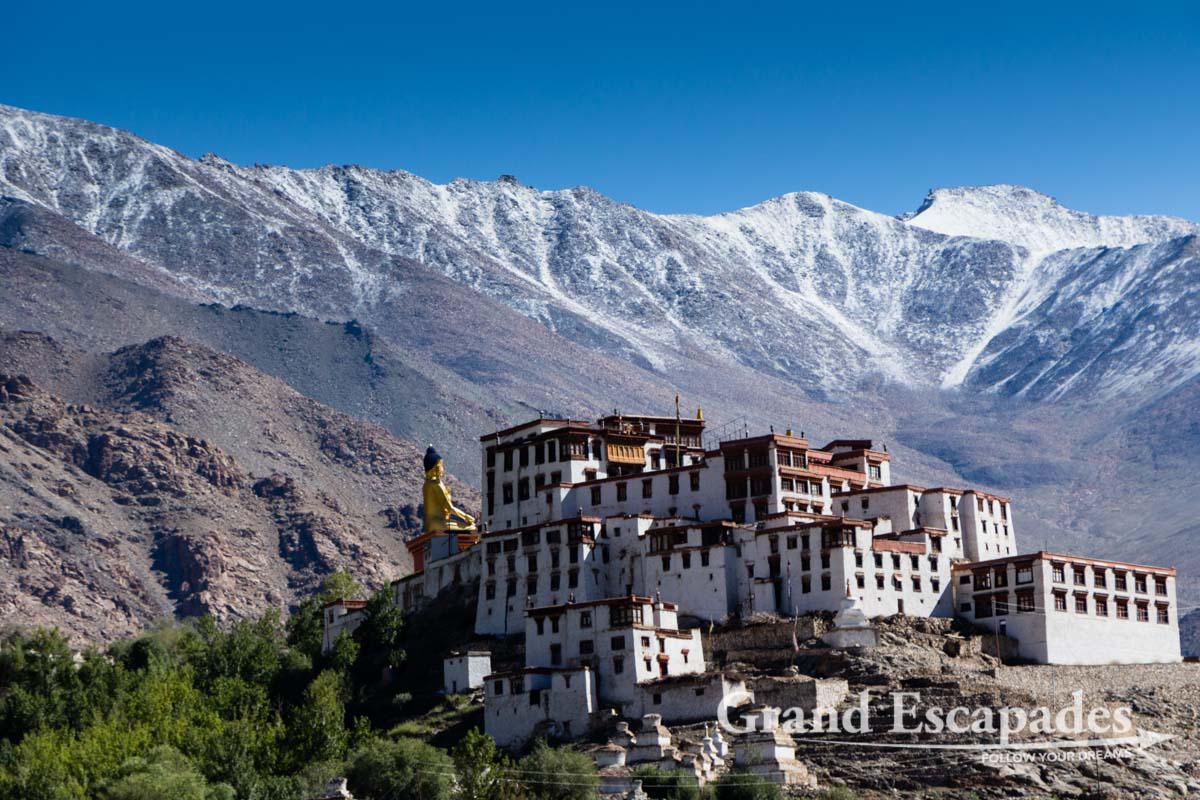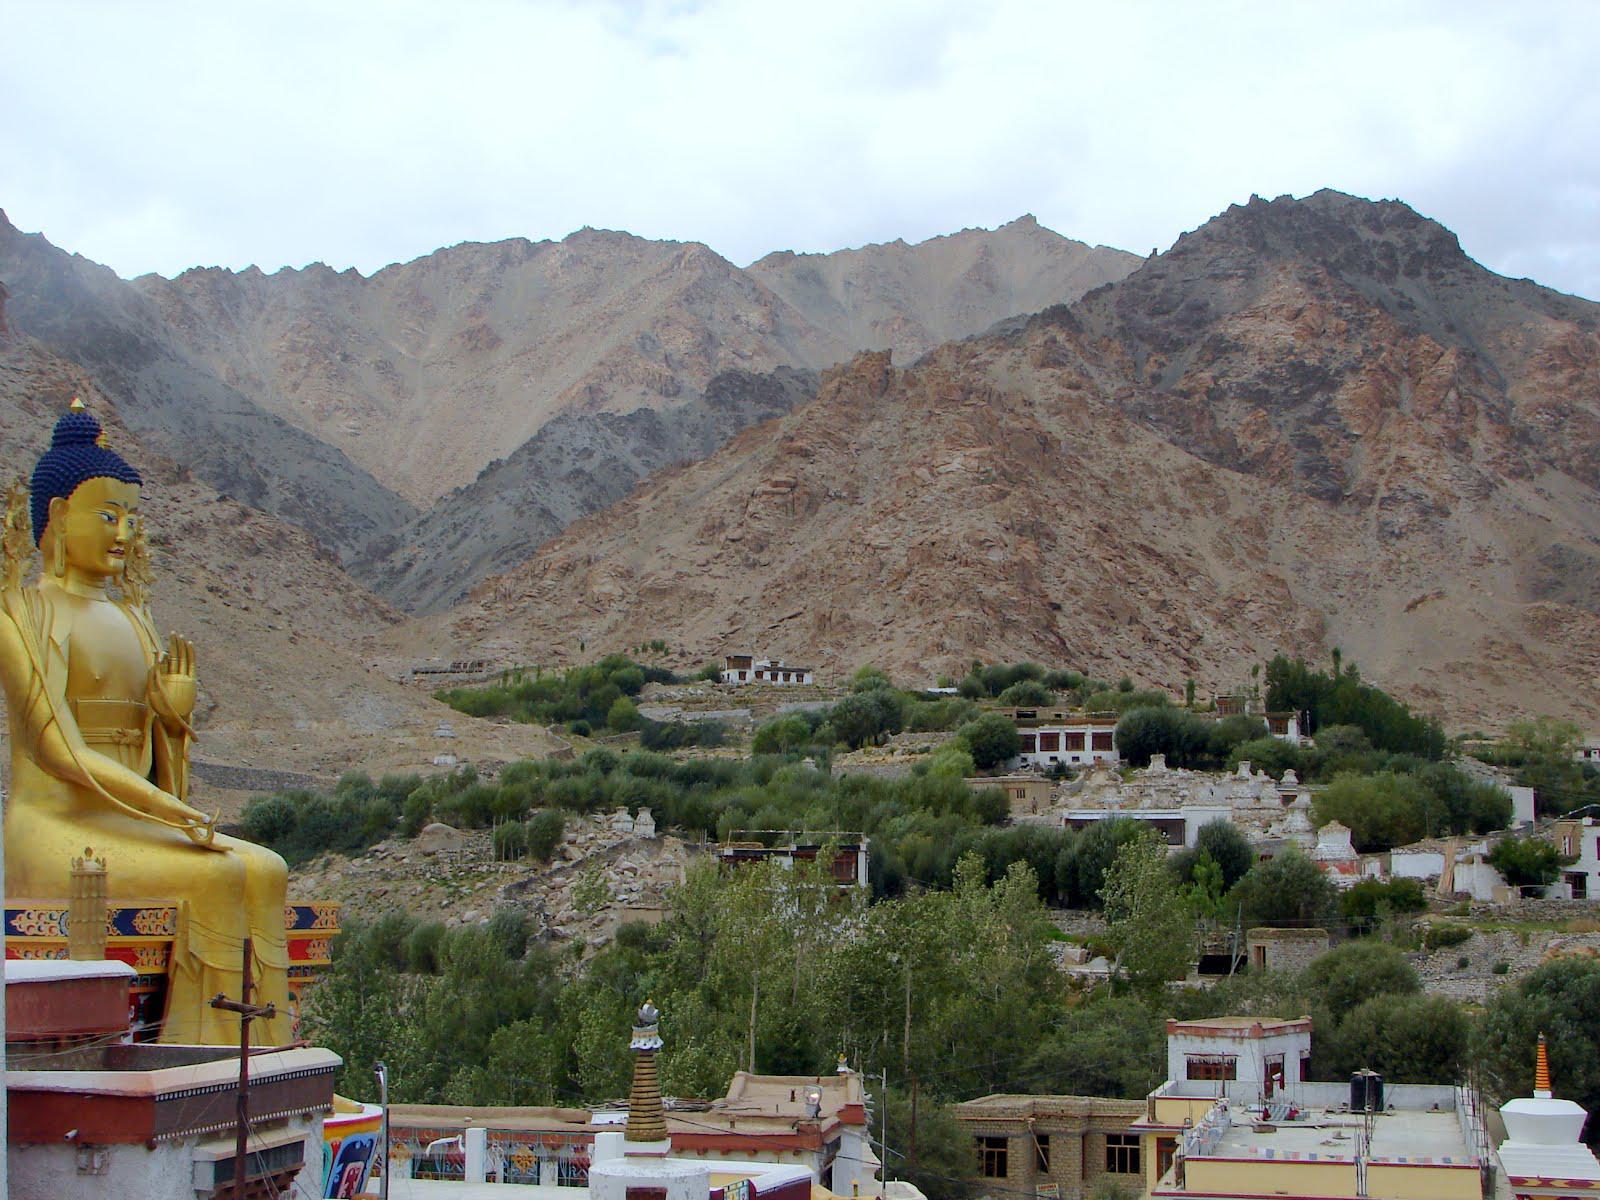The first image is the image on the left, the second image is the image on the right. Assess this claim about the two images: "A large golden shrine in the image of a person can be seen in both images.". Correct or not? Answer yes or no. Yes. 